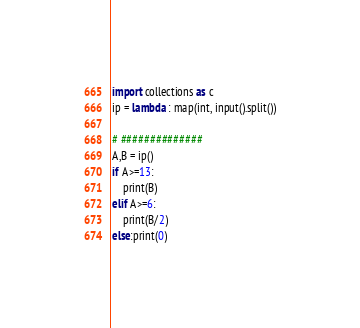<code> <loc_0><loc_0><loc_500><loc_500><_Python_>import collections as c
ip = lambda : map(int, input().split())

# ##############
A,B = ip()
if A>=13:
    print(B)
elif A>=6:
    print(B/2)
else:print(0)</code> 